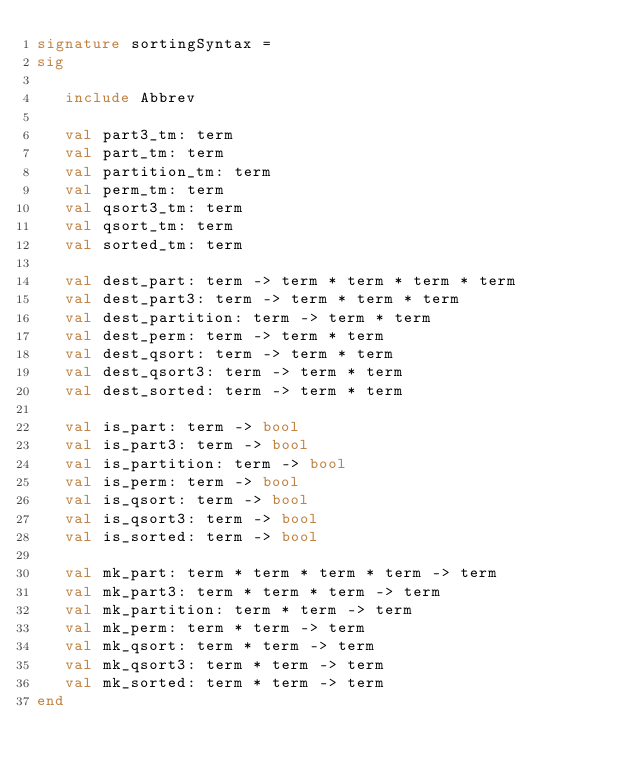<code> <loc_0><loc_0><loc_500><loc_500><_SML_>signature sortingSyntax =
sig

   include Abbrev

   val part3_tm: term
   val part_tm: term
   val partition_tm: term
   val perm_tm: term
   val qsort3_tm: term
   val qsort_tm: term
   val sorted_tm: term

   val dest_part: term -> term * term * term * term
   val dest_part3: term -> term * term * term
   val dest_partition: term -> term * term
   val dest_perm: term -> term * term
   val dest_qsort: term -> term * term
   val dest_qsort3: term -> term * term
   val dest_sorted: term -> term * term

   val is_part: term -> bool
   val is_part3: term -> bool
   val is_partition: term -> bool
   val is_perm: term -> bool
   val is_qsort: term -> bool
   val is_qsort3: term -> bool
   val is_sorted: term -> bool

   val mk_part: term * term * term * term -> term
   val mk_part3: term * term * term -> term
   val mk_partition: term * term -> term
   val mk_perm: term * term -> term
   val mk_qsort: term * term -> term
   val mk_qsort3: term * term -> term
   val mk_sorted: term * term -> term
end
</code> 